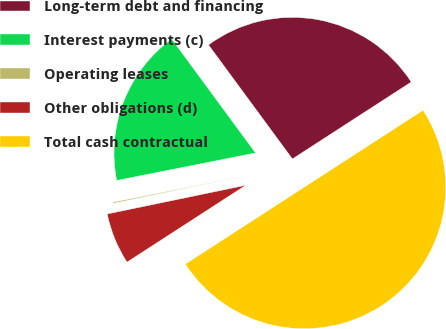Convert chart to OTSL. <chart><loc_0><loc_0><loc_500><loc_500><pie_chart><fcel>Long-term debt and financing<fcel>Interest payments (c)<fcel>Operating leases<fcel>Other obligations (d)<fcel>Total cash contractual<nl><fcel>25.95%<fcel>18.02%<fcel>0.14%<fcel>5.89%<fcel>50.0%<nl></chart> 